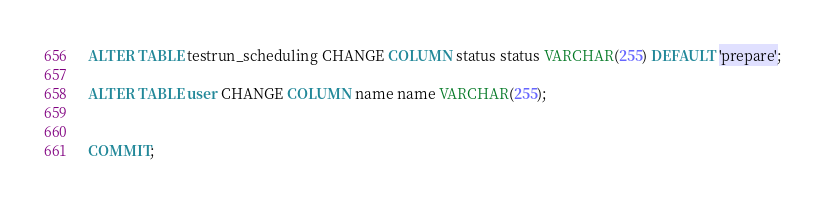Convert code to text. <code><loc_0><loc_0><loc_500><loc_500><_SQL_>ALTER TABLE testrun_scheduling CHANGE COLUMN status status VARCHAR(255) DEFAULT 'prepare';

ALTER TABLE user CHANGE COLUMN name name VARCHAR(255);


COMMIT;

</code> 